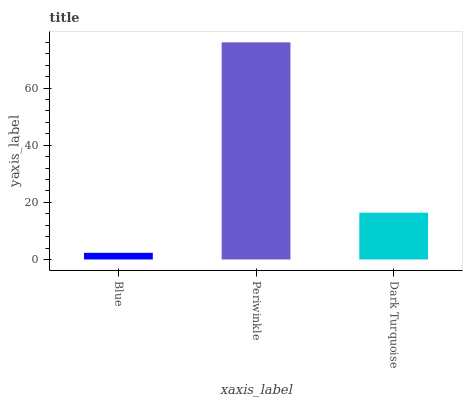Is Blue the minimum?
Answer yes or no. Yes. Is Periwinkle the maximum?
Answer yes or no. Yes. Is Dark Turquoise the minimum?
Answer yes or no. No. Is Dark Turquoise the maximum?
Answer yes or no. No. Is Periwinkle greater than Dark Turquoise?
Answer yes or no. Yes. Is Dark Turquoise less than Periwinkle?
Answer yes or no. Yes. Is Dark Turquoise greater than Periwinkle?
Answer yes or no. No. Is Periwinkle less than Dark Turquoise?
Answer yes or no. No. Is Dark Turquoise the high median?
Answer yes or no. Yes. Is Dark Turquoise the low median?
Answer yes or no. Yes. Is Blue the high median?
Answer yes or no. No. Is Periwinkle the low median?
Answer yes or no. No. 